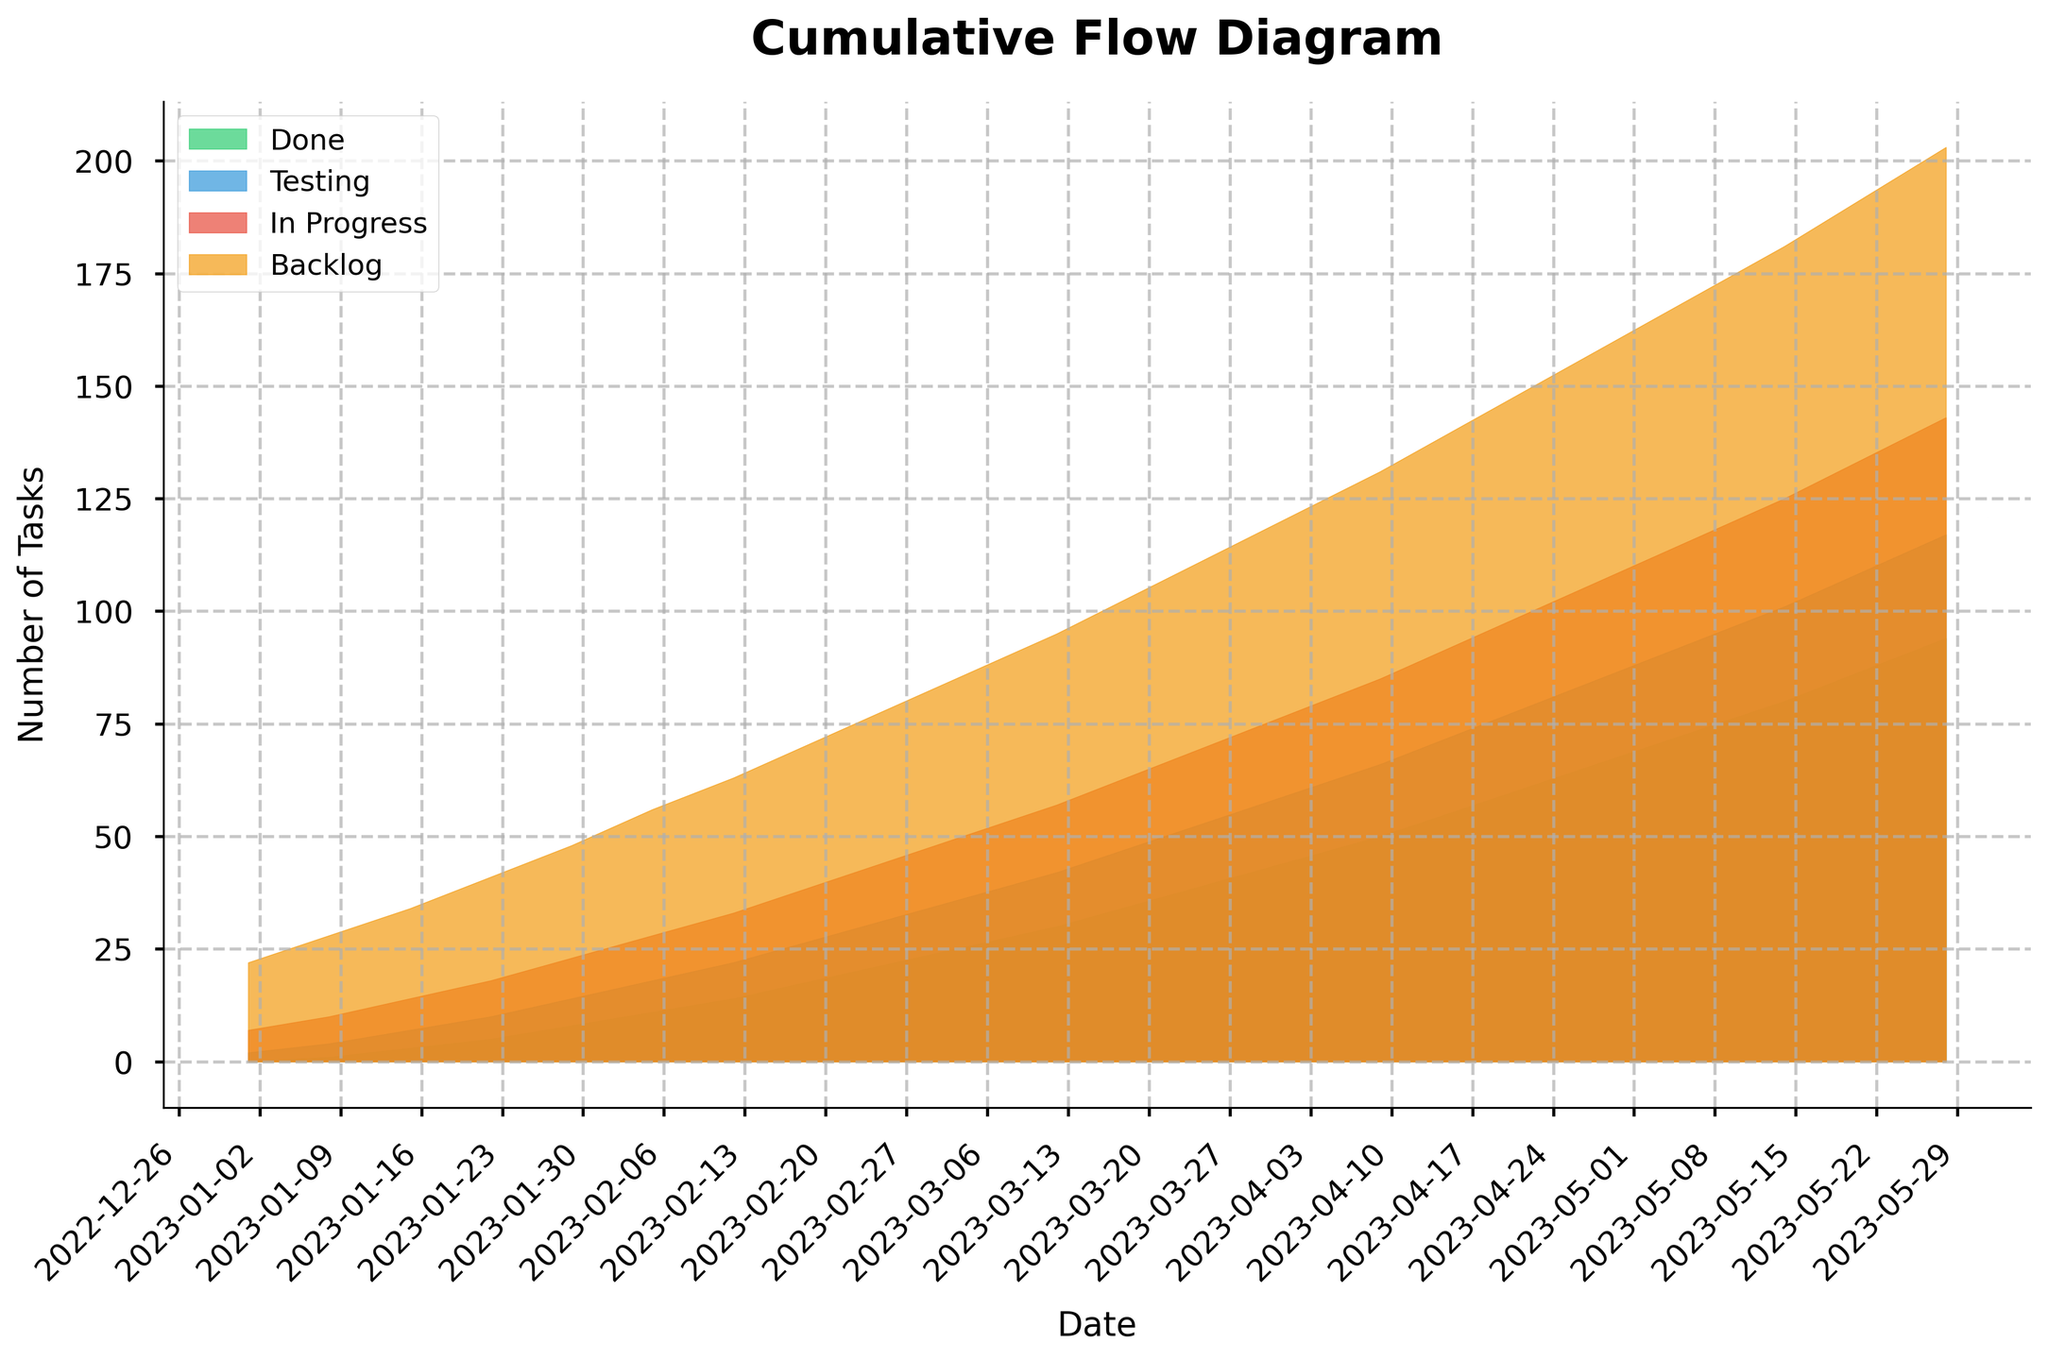What's the earliest date shown on the graph? The horizontal axis displays the dates starting from "2023-01-01." By identifying the earliest date on this axis, we can determine the answer.
Answer: 2023-01-01 What is the total number of tasks on 2023-04-02? To find the total number of tasks on this date, sum the values of the Backlog, In Progress, Testing, and Done tasks at that date: 44 + 18 + 15 + 45.
Answer: 122 Which category shows the greatest increase in tasks between 2023-01-01 and 2023-05-28? By observing the values of all categories from the start date to the end date, we see the changes: Backlog grows from 15 to 60 (an increase of 45), In Progress grows from 5 to 26 (an increase of 21), Testing grows from 2 to 23 (an increase of 21), and Done grows from 0 to 94 (an increase of 94). The Done category shows the greatest increase.
Answer: Done On which date did the 'Testing' category exceed 10 tasks for the first time? By looking at the 'Testing' line across dates, the value first exceeds 10 tasks around the date "2023-02-26" where it reaches 10.
Answer: 2023-02-26 How many tasks were marked 'Done' by the end of March 2023? By looking at the cumulative tasks in the 'Done' category on "2023-03-26", we find 40 tasks were marked as 'Done'.
Answer: 40 Which month shows the highest number of tasks in the 'In Progress' category? Observing the 'In Progress' values across months, the maximum number of tasks (26) appears in May.
Answer: May By how many tasks did the 'Backlog' category increase from February 12, 2023, to March 26, 2023? The 'Backlog' value on 2023-02-12 is 30 and on 2023-03-26 is 42. The increase is calculated as 42 - 30.
Answer: 12 What is the visual color associated with the 'Testing' category on the graph? By observing the color coding on the legend of the graph, 'Testing' is represented with a blue color.
Answer: Blue Is there any date when the number of 'Backlog' tasks is equal to the sum of 'In Progress' and 'Testing' tasks? For each date, check whether the 'Backlog' tasks equal the combined total of 'In Progress' and 'Testing' tasks. On 2023-03-12, Backlog is 38, In Progress + Testing is 15 + 12 = 27, so no such date exists.
Answer: No 